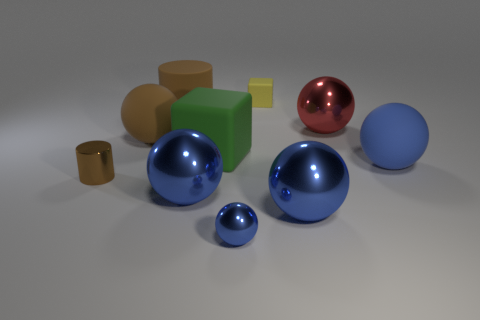Subtract all blue balls. How many were subtracted if there are2blue balls left? 2 Subtract all green blocks. How many blue balls are left? 4 Subtract 3 spheres. How many spheres are left? 3 Subtract all brown spheres. How many spheres are left? 5 Subtract all brown spheres. How many spheres are left? 5 Subtract all purple spheres. Subtract all brown cylinders. How many spheres are left? 6 Subtract all cylinders. How many objects are left? 8 Subtract 0 cyan cylinders. How many objects are left? 10 Subtract all large red shiny spheres. Subtract all red balls. How many objects are left? 8 Add 3 small yellow blocks. How many small yellow blocks are left? 4 